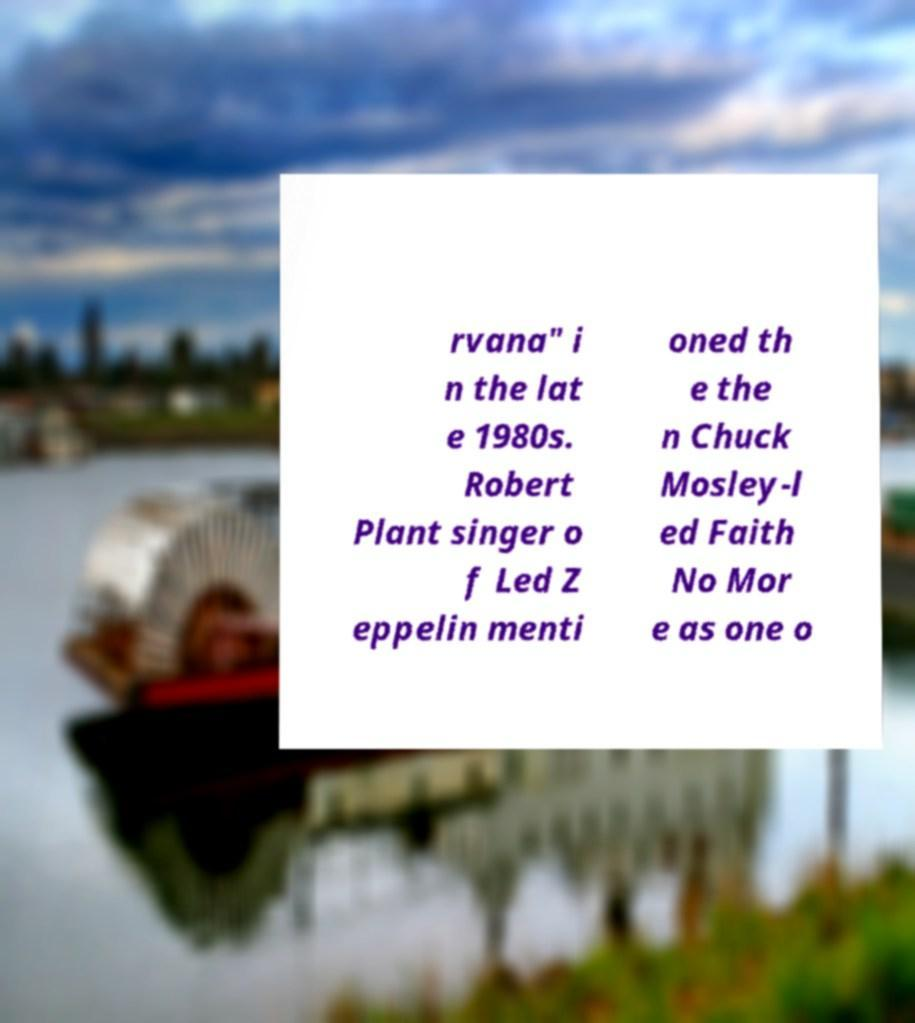For documentation purposes, I need the text within this image transcribed. Could you provide that? rvana" i n the lat e 1980s. Robert Plant singer o f Led Z eppelin menti oned th e the n Chuck Mosley-l ed Faith No Mor e as one o 